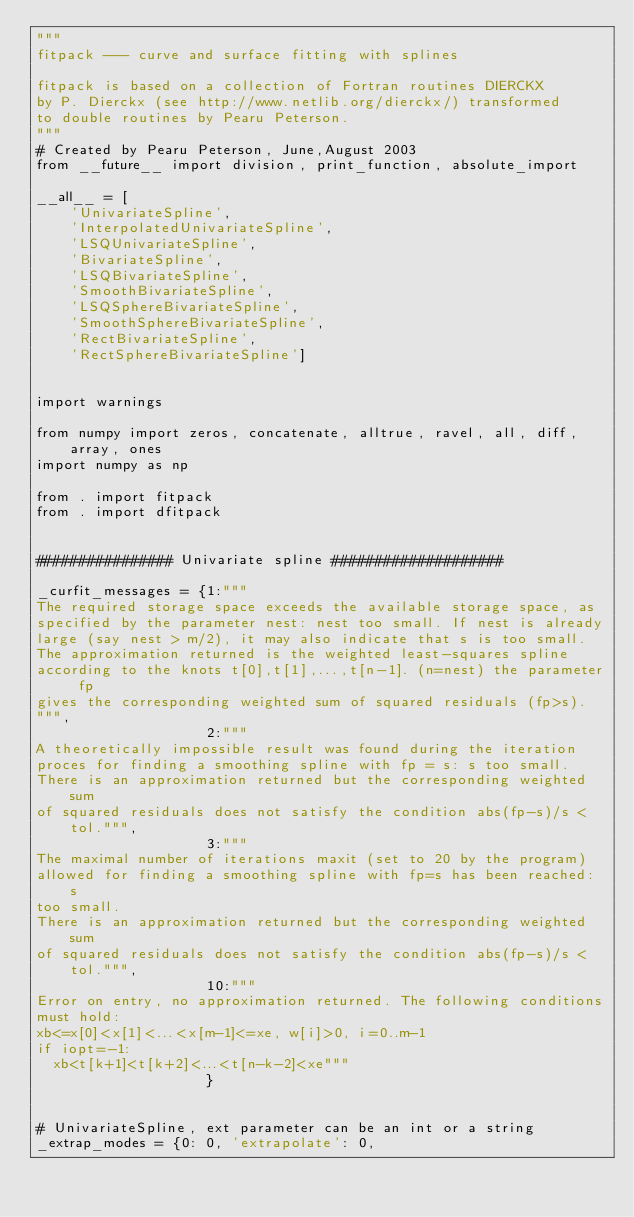<code> <loc_0><loc_0><loc_500><loc_500><_Python_>"""
fitpack --- curve and surface fitting with splines

fitpack is based on a collection of Fortran routines DIERCKX
by P. Dierckx (see http://www.netlib.org/dierckx/) transformed
to double routines by Pearu Peterson.
"""
# Created by Pearu Peterson, June,August 2003
from __future__ import division, print_function, absolute_import

__all__ = [
    'UnivariateSpline',
    'InterpolatedUnivariateSpline',
    'LSQUnivariateSpline',
    'BivariateSpline',
    'LSQBivariateSpline',
    'SmoothBivariateSpline',
    'LSQSphereBivariateSpline',
    'SmoothSphereBivariateSpline',
    'RectBivariateSpline',
    'RectSphereBivariateSpline']


import warnings

from numpy import zeros, concatenate, alltrue, ravel, all, diff, array, ones
import numpy as np

from . import fitpack
from . import dfitpack


################ Univariate spline ####################

_curfit_messages = {1:"""
The required storage space exceeds the available storage space, as
specified by the parameter nest: nest too small. If nest is already
large (say nest > m/2), it may also indicate that s is too small.
The approximation returned is the weighted least-squares spline
according to the knots t[0],t[1],...,t[n-1]. (n=nest) the parameter fp
gives the corresponding weighted sum of squared residuals (fp>s).
""",
                    2:"""
A theoretically impossible result was found during the iteration
proces for finding a smoothing spline with fp = s: s too small.
There is an approximation returned but the corresponding weighted sum
of squared residuals does not satisfy the condition abs(fp-s)/s < tol.""",
                    3:"""
The maximal number of iterations maxit (set to 20 by the program)
allowed for finding a smoothing spline with fp=s has been reached: s
too small.
There is an approximation returned but the corresponding weighted sum
of squared residuals does not satisfy the condition abs(fp-s)/s < tol.""",
                    10:"""
Error on entry, no approximation returned. The following conditions
must hold:
xb<=x[0]<x[1]<...<x[m-1]<=xe, w[i]>0, i=0..m-1
if iopt=-1:
  xb<t[k+1]<t[k+2]<...<t[n-k-2]<xe"""
                    }


# UnivariateSpline, ext parameter can be an int or a string
_extrap_modes = {0: 0, 'extrapolate': 0,</code> 